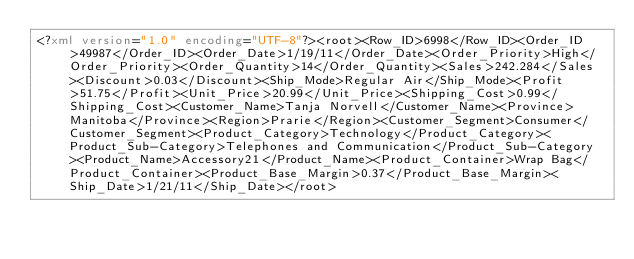<code> <loc_0><loc_0><loc_500><loc_500><_XML_><?xml version="1.0" encoding="UTF-8"?><root><Row_ID>6998</Row_ID><Order_ID>49987</Order_ID><Order_Date>1/19/11</Order_Date><Order_Priority>High</Order_Priority><Order_Quantity>14</Order_Quantity><Sales>242.284</Sales><Discount>0.03</Discount><Ship_Mode>Regular Air</Ship_Mode><Profit>51.75</Profit><Unit_Price>20.99</Unit_Price><Shipping_Cost>0.99</Shipping_Cost><Customer_Name>Tanja Norvell</Customer_Name><Province>Manitoba</Province><Region>Prarie</Region><Customer_Segment>Consumer</Customer_Segment><Product_Category>Technology</Product_Category><Product_Sub-Category>Telephones and Communication</Product_Sub-Category><Product_Name>Accessory21</Product_Name><Product_Container>Wrap Bag</Product_Container><Product_Base_Margin>0.37</Product_Base_Margin><Ship_Date>1/21/11</Ship_Date></root></code> 